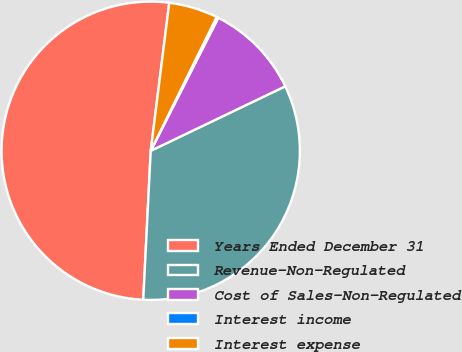Convert chart to OTSL. <chart><loc_0><loc_0><loc_500><loc_500><pie_chart><fcel>Years Ended December 31<fcel>Revenue-Non-Regulated<fcel>Cost of Sales-Non-Regulated<fcel>Interest income<fcel>Interest expense<nl><fcel>51.18%<fcel>32.91%<fcel>10.4%<fcel>0.2%<fcel>5.3%<nl></chart> 